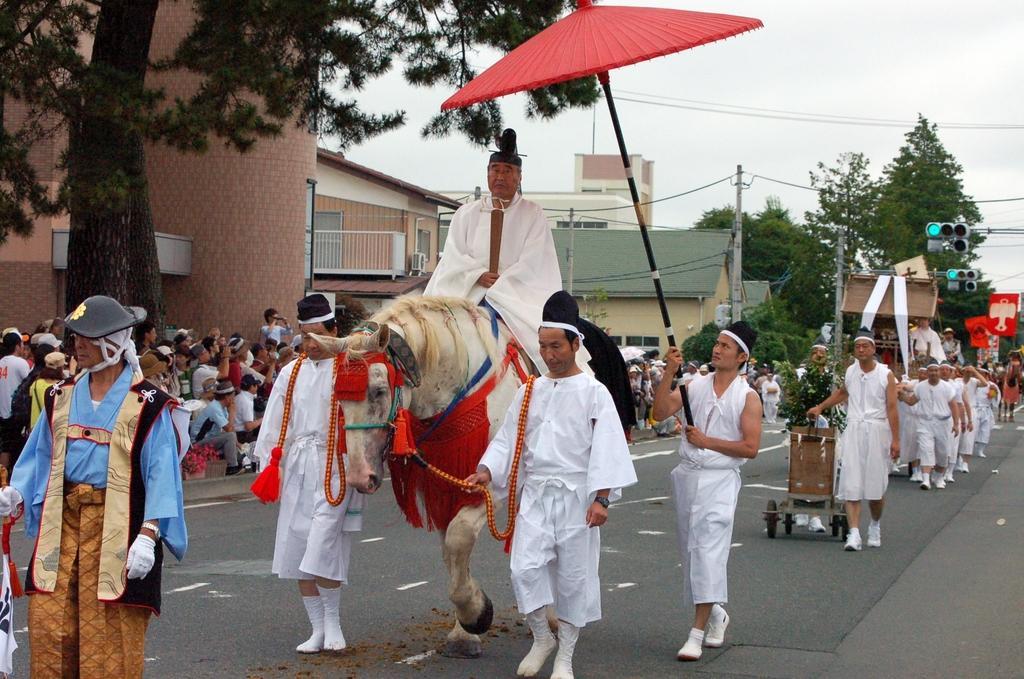Can you describe this image briefly? In this picture there are many people standing in the road who are dressed in white color,a guy who is sitting in a horse and the other person is catching an umbrella. In the background there are many houses. 